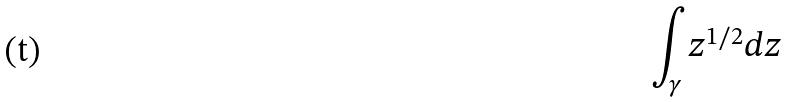<formula> <loc_0><loc_0><loc_500><loc_500>\int _ { \gamma } z ^ { 1 / 2 } d z</formula> 